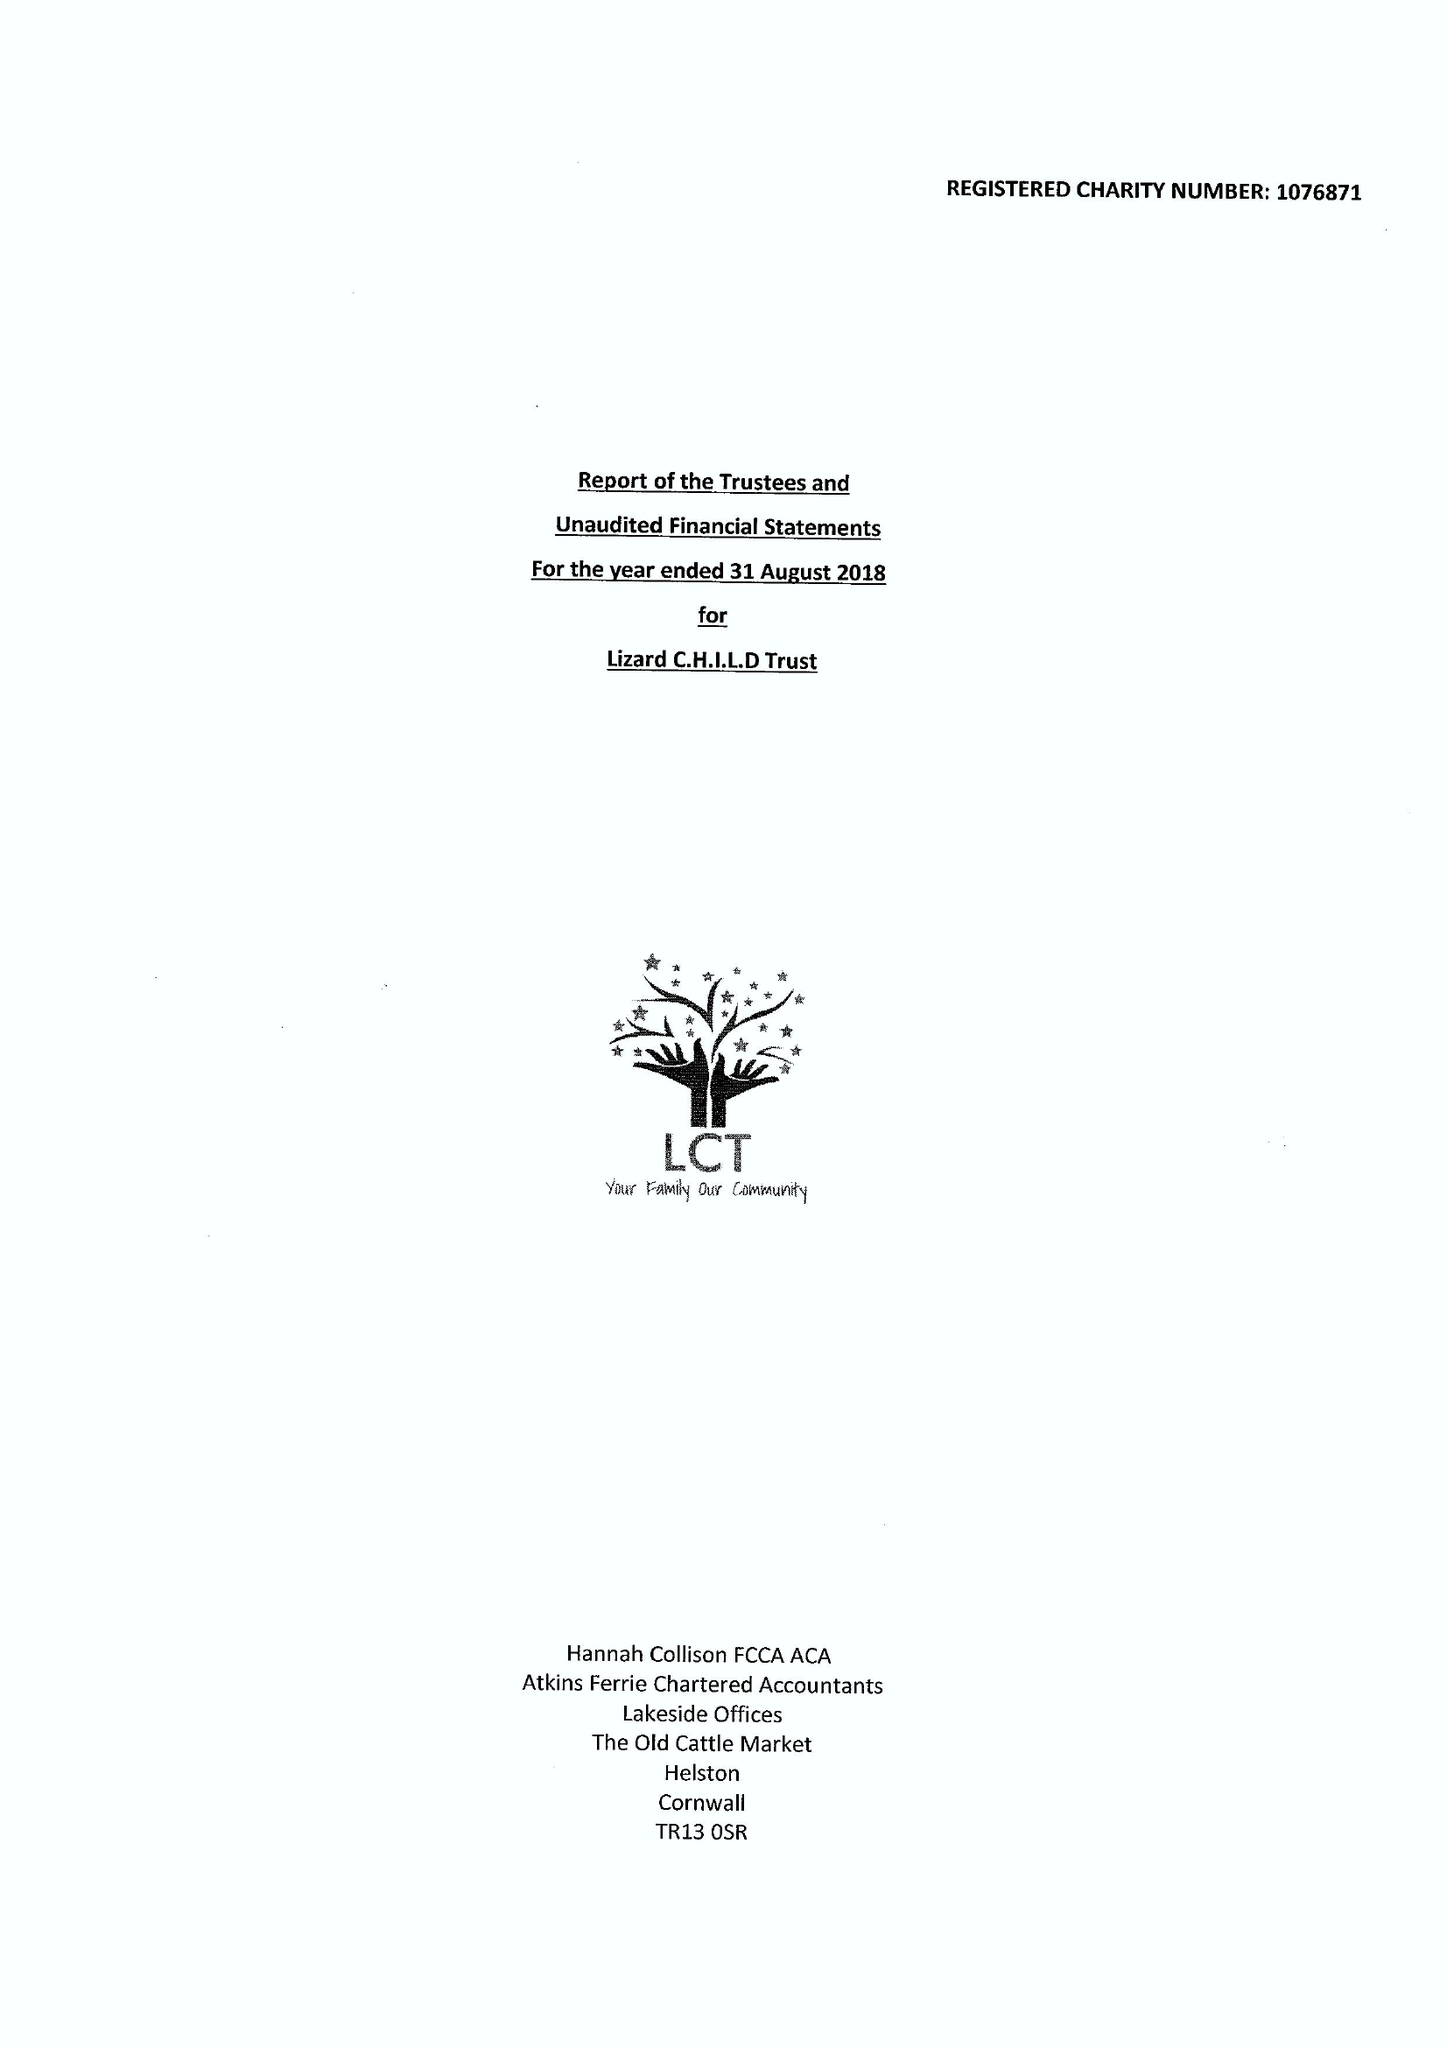What is the value for the address__street_line?
Answer the question using a single word or phrase. PENBERTHY ROAD 